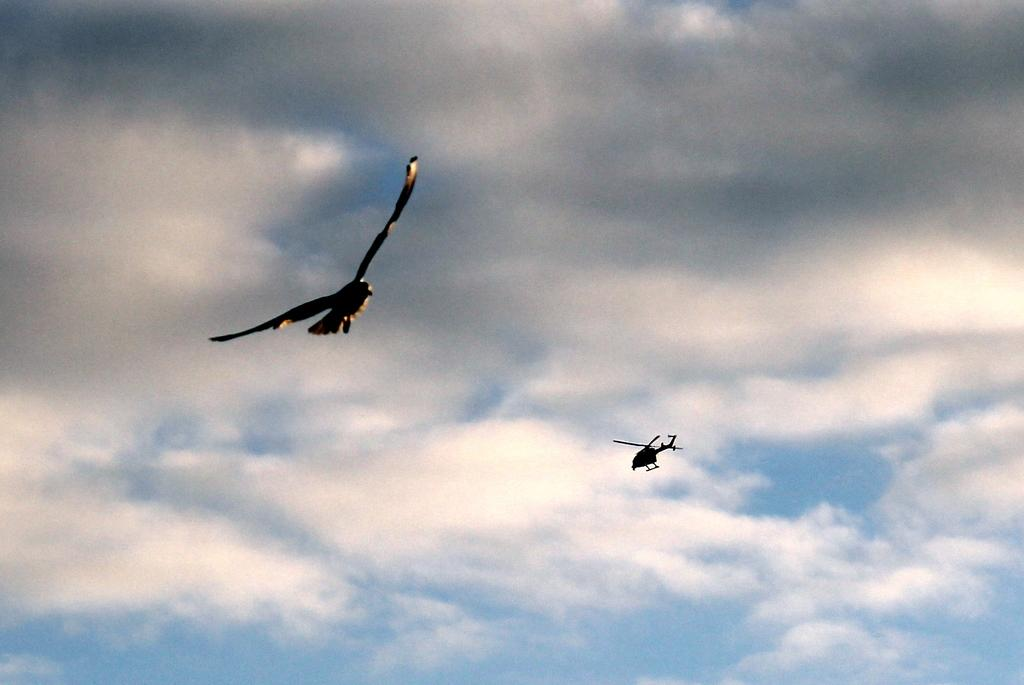What is the main subject of the image? The main subject of the image is a helicopter. Can you describe any other objects or living beings in the image? Yes, there is a bird flying in the sky in the image. What type of zephyr can be seen in the image? There is no zephyr present in the image; a zephyr refers to a gentle breeze, which is not visible in the image. 